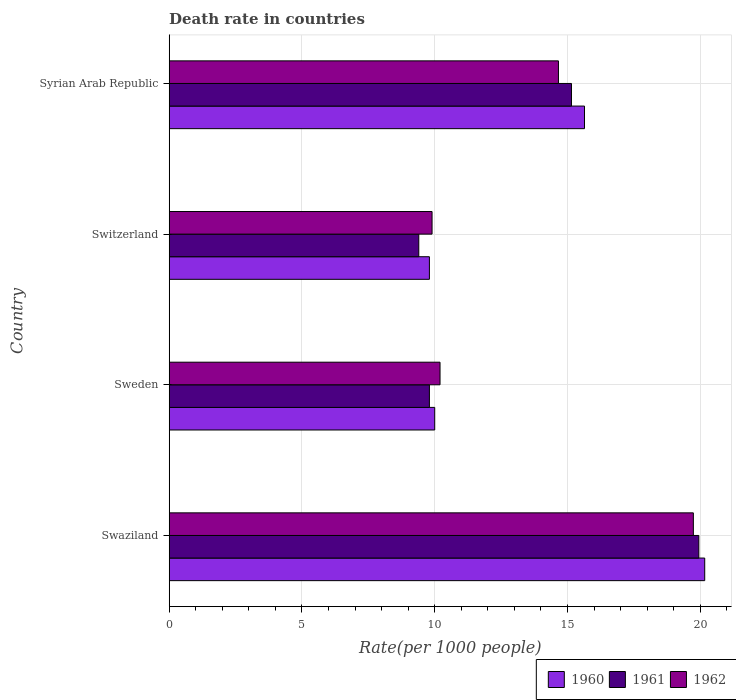Are the number of bars per tick equal to the number of legend labels?
Provide a succinct answer. Yes. How many bars are there on the 4th tick from the top?
Provide a succinct answer. 3. What is the label of the 2nd group of bars from the top?
Provide a short and direct response. Switzerland. Across all countries, what is the maximum death rate in 1961?
Offer a terse response. 19.95. Across all countries, what is the minimum death rate in 1960?
Keep it short and to the point. 9.8. In which country was the death rate in 1961 maximum?
Your answer should be compact. Swaziland. In which country was the death rate in 1960 minimum?
Provide a succinct answer. Switzerland. What is the total death rate in 1962 in the graph?
Provide a short and direct response. 54.5. What is the difference between the death rate in 1960 in Switzerland and that in Syrian Arab Republic?
Make the answer very short. -5.84. What is the difference between the death rate in 1962 in Switzerland and the death rate in 1960 in Swaziland?
Keep it short and to the point. -10.27. What is the average death rate in 1960 per country?
Your answer should be very brief. 13.9. What is the difference between the death rate in 1961 and death rate in 1962 in Swaziland?
Your answer should be compact. 0.21. In how many countries, is the death rate in 1960 greater than 17 ?
Provide a short and direct response. 1. What is the ratio of the death rate in 1961 in Switzerland to that in Syrian Arab Republic?
Provide a short and direct response. 0.62. What is the difference between the highest and the second highest death rate in 1960?
Ensure brevity in your answer.  4.53. What is the difference between the highest and the lowest death rate in 1960?
Offer a very short reply. 10.37. In how many countries, is the death rate in 1960 greater than the average death rate in 1960 taken over all countries?
Provide a succinct answer. 2. What does the 1st bar from the top in Syrian Arab Republic represents?
Provide a short and direct response. 1962. What does the 1st bar from the bottom in Syrian Arab Republic represents?
Your answer should be compact. 1960. How many bars are there?
Ensure brevity in your answer.  12. Are all the bars in the graph horizontal?
Provide a short and direct response. Yes. Are the values on the major ticks of X-axis written in scientific E-notation?
Keep it short and to the point. No. Does the graph contain any zero values?
Ensure brevity in your answer.  No. Does the graph contain grids?
Make the answer very short. Yes. How many legend labels are there?
Your answer should be very brief. 3. How are the legend labels stacked?
Ensure brevity in your answer.  Horizontal. What is the title of the graph?
Your answer should be very brief. Death rate in countries. Does "1969" appear as one of the legend labels in the graph?
Your answer should be very brief. No. What is the label or title of the X-axis?
Give a very brief answer. Rate(per 1000 people). What is the label or title of the Y-axis?
Offer a very short reply. Country. What is the Rate(per 1000 people) in 1960 in Swaziland?
Your response must be concise. 20.17. What is the Rate(per 1000 people) in 1961 in Swaziland?
Give a very brief answer. 19.95. What is the Rate(per 1000 people) of 1962 in Swaziland?
Make the answer very short. 19.74. What is the Rate(per 1000 people) of 1961 in Sweden?
Make the answer very short. 9.8. What is the Rate(per 1000 people) in 1962 in Sweden?
Give a very brief answer. 10.2. What is the Rate(per 1000 people) of 1960 in Switzerland?
Your answer should be compact. 9.8. What is the Rate(per 1000 people) in 1961 in Switzerland?
Offer a very short reply. 9.4. What is the Rate(per 1000 people) in 1962 in Switzerland?
Make the answer very short. 9.9. What is the Rate(per 1000 people) in 1960 in Syrian Arab Republic?
Ensure brevity in your answer.  15.64. What is the Rate(per 1000 people) of 1961 in Syrian Arab Republic?
Provide a short and direct response. 15.15. What is the Rate(per 1000 people) of 1962 in Syrian Arab Republic?
Make the answer very short. 14.66. Across all countries, what is the maximum Rate(per 1000 people) in 1960?
Offer a very short reply. 20.17. Across all countries, what is the maximum Rate(per 1000 people) of 1961?
Give a very brief answer. 19.95. Across all countries, what is the maximum Rate(per 1000 people) in 1962?
Your response must be concise. 19.74. Across all countries, what is the minimum Rate(per 1000 people) in 1960?
Your response must be concise. 9.8. Across all countries, what is the minimum Rate(per 1000 people) in 1961?
Your response must be concise. 9.4. What is the total Rate(per 1000 people) of 1960 in the graph?
Your answer should be compact. 55.61. What is the total Rate(per 1000 people) in 1961 in the graph?
Provide a short and direct response. 54.3. What is the total Rate(per 1000 people) of 1962 in the graph?
Provide a succinct answer. 54.5. What is the difference between the Rate(per 1000 people) of 1960 in Swaziland and that in Sweden?
Your answer should be compact. 10.17. What is the difference between the Rate(per 1000 people) of 1961 in Swaziland and that in Sweden?
Your answer should be very brief. 10.15. What is the difference between the Rate(per 1000 people) in 1962 in Swaziland and that in Sweden?
Offer a terse response. 9.54. What is the difference between the Rate(per 1000 people) in 1960 in Swaziland and that in Switzerland?
Your answer should be compact. 10.37. What is the difference between the Rate(per 1000 people) in 1961 in Swaziland and that in Switzerland?
Offer a very short reply. 10.55. What is the difference between the Rate(per 1000 people) of 1962 in Swaziland and that in Switzerland?
Provide a short and direct response. 9.84. What is the difference between the Rate(per 1000 people) of 1960 in Swaziland and that in Syrian Arab Republic?
Your answer should be very brief. 4.53. What is the difference between the Rate(per 1000 people) in 1961 in Swaziland and that in Syrian Arab Republic?
Your response must be concise. 4.8. What is the difference between the Rate(per 1000 people) in 1962 in Swaziland and that in Syrian Arab Republic?
Make the answer very short. 5.08. What is the difference between the Rate(per 1000 people) of 1960 in Sweden and that in Switzerland?
Offer a terse response. 0.2. What is the difference between the Rate(per 1000 people) in 1961 in Sweden and that in Switzerland?
Your response must be concise. 0.4. What is the difference between the Rate(per 1000 people) in 1960 in Sweden and that in Syrian Arab Republic?
Offer a terse response. -5.64. What is the difference between the Rate(per 1000 people) of 1961 in Sweden and that in Syrian Arab Republic?
Your response must be concise. -5.35. What is the difference between the Rate(per 1000 people) in 1962 in Sweden and that in Syrian Arab Republic?
Your answer should be very brief. -4.46. What is the difference between the Rate(per 1000 people) in 1960 in Switzerland and that in Syrian Arab Republic?
Ensure brevity in your answer.  -5.84. What is the difference between the Rate(per 1000 people) of 1961 in Switzerland and that in Syrian Arab Republic?
Your response must be concise. -5.75. What is the difference between the Rate(per 1000 people) of 1962 in Switzerland and that in Syrian Arab Republic?
Provide a succinct answer. -4.76. What is the difference between the Rate(per 1000 people) in 1960 in Swaziland and the Rate(per 1000 people) in 1961 in Sweden?
Offer a very short reply. 10.37. What is the difference between the Rate(per 1000 people) in 1960 in Swaziland and the Rate(per 1000 people) in 1962 in Sweden?
Keep it short and to the point. 9.97. What is the difference between the Rate(per 1000 people) of 1961 in Swaziland and the Rate(per 1000 people) of 1962 in Sweden?
Provide a succinct answer. 9.75. What is the difference between the Rate(per 1000 people) of 1960 in Swaziland and the Rate(per 1000 people) of 1961 in Switzerland?
Your answer should be very brief. 10.77. What is the difference between the Rate(per 1000 people) in 1960 in Swaziland and the Rate(per 1000 people) in 1962 in Switzerland?
Your answer should be very brief. 10.27. What is the difference between the Rate(per 1000 people) of 1961 in Swaziland and the Rate(per 1000 people) of 1962 in Switzerland?
Give a very brief answer. 10.05. What is the difference between the Rate(per 1000 people) of 1960 in Swaziland and the Rate(per 1000 people) of 1961 in Syrian Arab Republic?
Make the answer very short. 5.02. What is the difference between the Rate(per 1000 people) in 1960 in Swaziland and the Rate(per 1000 people) in 1962 in Syrian Arab Republic?
Offer a terse response. 5.51. What is the difference between the Rate(per 1000 people) in 1961 in Swaziland and the Rate(per 1000 people) in 1962 in Syrian Arab Republic?
Your answer should be very brief. 5.29. What is the difference between the Rate(per 1000 people) in 1960 in Sweden and the Rate(per 1000 people) in 1961 in Switzerland?
Provide a short and direct response. 0.6. What is the difference between the Rate(per 1000 people) of 1960 in Sweden and the Rate(per 1000 people) of 1962 in Switzerland?
Provide a short and direct response. 0.1. What is the difference between the Rate(per 1000 people) of 1961 in Sweden and the Rate(per 1000 people) of 1962 in Switzerland?
Offer a very short reply. -0.1. What is the difference between the Rate(per 1000 people) of 1960 in Sweden and the Rate(per 1000 people) of 1961 in Syrian Arab Republic?
Your answer should be very brief. -5.15. What is the difference between the Rate(per 1000 people) in 1960 in Sweden and the Rate(per 1000 people) in 1962 in Syrian Arab Republic?
Offer a terse response. -4.66. What is the difference between the Rate(per 1000 people) in 1961 in Sweden and the Rate(per 1000 people) in 1962 in Syrian Arab Republic?
Your answer should be compact. -4.86. What is the difference between the Rate(per 1000 people) of 1960 in Switzerland and the Rate(per 1000 people) of 1961 in Syrian Arab Republic?
Your answer should be very brief. -5.35. What is the difference between the Rate(per 1000 people) of 1960 in Switzerland and the Rate(per 1000 people) of 1962 in Syrian Arab Republic?
Your answer should be very brief. -4.86. What is the difference between the Rate(per 1000 people) of 1961 in Switzerland and the Rate(per 1000 people) of 1962 in Syrian Arab Republic?
Your answer should be very brief. -5.26. What is the average Rate(per 1000 people) of 1960 per country?
Offer a very short reply. 13.9. What is the average Rate(per 1000 people) of 1961 per country?
Keep it short and to the point. 13.57. What is the average Rate(per 1000 people) in 1962 per country?
Offer a terse response. 13.63. What is the difference between the Rate(per 1000 people) of 1960 and Rate(per 1000 people) of 1961 in Swaziland?
Ensure brevity in your answer.  0.22. What is the difference between the Rate(per 1000 people) of 1960 and Rate(per 1000 people) of 1962 in Swaziland?
Your response must be concise. 0.43. What is the difference between the Rate(per 1000 people) of 1961 and Rate(per 1000 people) of 1962 in Swaziland?
Give a very brief answer. 0.21. What is the difference between the Rate(per 1000 people) of 1960 and Rate(per 1000 people) of 1962 in Sweden?
Keep it short and to the point. -0.2. What is the difference between the Rate(per 1000 people) of 1961 and Rate(per 1000 people) of 1962 in Sweden?
Offer a terse response. -0.4. What is the difference between the Rate(per 1000 people) in 1961 and Rate(per 1000 people) in 1962 in Switzerland?
Provide a short and direct response. -0.5. What is the difference between the Rate(per 1000 people) in 1960 and Rate(per 1000 people) in 1961 in Syrian Arab Republic?
Your answer should be very brief. 0.49. What is the difference between the Rate(per 1000 people) of 1960 and Rate(per 1000 people) of 1962 in Syrian Arab Republic?
Provide a short and direct response. 0.98. What is the difference between the Rate(per 1000 people) in 1961 and Rate(per 1000 people) in 1962 in Syrian Arab Republic?
Give a very brief answer. 0.49. What is the ratio of the Rate(per 1000 people) of 1960 in Swaziland to that in Sweden?
Offer a terse response. 2.02. What is the ratio of the Rate(per 1000 people) in 1961 in Swaziland to that in Sweden?
Offer a very short reply. 2.04. What is the ratio of the Rate(per 1000 people) of 1962 in Swaziland to that in Sweden?
Offer a terse response. 1.94. What is the ratio of the Rate(per 1000 people) in 1960 in Swaziland to that in Switzerland?
Your answer should be very brief. 2.06. What is the ratio of the Rate(per 1000 people) in 1961 in Swaziland to that in Switzerland?
Keep it short and to the point. 2.12. What is the ratio of the Rate(per 1000 people) in 1962 in Swaziland to that in Switzerland?
Keep it short and to the point. 1.99. What is the ratio of the Rate(per 1000 people) of 1960 in Swaziland to that in Syrian Arab Republic?
Your response must be concise. 1.29. What is the ratio of the Rate(per 1000 people) of 1961 in Swaziland to that in Syrian Arab Republic?
Offer a very short reply. 1.32. What is the ratio of the Rate(per 1000 people) of 1962 in Swaziland to that in Syrian Arab Republic?
Your answer should be very brief. 1.35. What is the ratio of the Rate(per 1000 people) in 1960 in Sweden to that in Switzerland?
Your answer should be very brief. 1.02. What is the ratio of the Rate(per 1000 people) of 1961 in Sweden to that in Switzerland?
Your answer should be very brief. 1.04. What is the ratio of the Rate(per 1000 people) in 1962 in Sweden to that in Switzerland?
Your answer should be very brief. 1.03. What is the ratio of the Rate(per 1000 people) of 1960 in Sweden to that in Syrian Arab Republic?
Provide a succinct answer. 0.64. What is the ratio of the Rate(per 1000 people) of 1961 in Sweden to that in Syrian Arab Republic?
Your answer should be very brief. 0.65. What is the ratio of the Rate(per 1000 people) in 1962 in Sweden to that in Syrian Arab Republic?
Make the answer very short. 0.7. What is the ratio of the Rate(per 1000 people) of 1960 in Switzerland to that in Syrian Arab Republic?
Provide a succinct answer. 0.63. What is the ratio of the Rate(per 1000 people) of 1961 in Switzerland to that in Syrian Arab Republic?
Offer a very short reply. 0.62. What is the ratio of the Rate(per 1000 people) in 1962 in Switzerland to that in Syrian Arab Republic?
Keep it short and to the point. 0.68. What is the difference between the highest and the second highest Rate(per 1000 people) in 1960?
Give a very brief answer. 4.53. What is the difference between the highest and the second highest Rate(per 1000 people) in 1961?
Offer a very short reply. 4.8. What is the difference between the highest and the second highest Rate(per 1000 people) of 1962?
Keep it short and to the point. 5.08. What is the difference between the highest and the lowest Rate(per 1000 people) in 1960?
Offer a very short reply. 10.37. What is the difference between the highest and the lowest Rate(per 1000 people) in 1961?
Give a very brief answer. 10.55. What is the difference between the highest and the lowest Rate(per 1000 people) of 1962?
Provide a succinct answer. 9.84. 